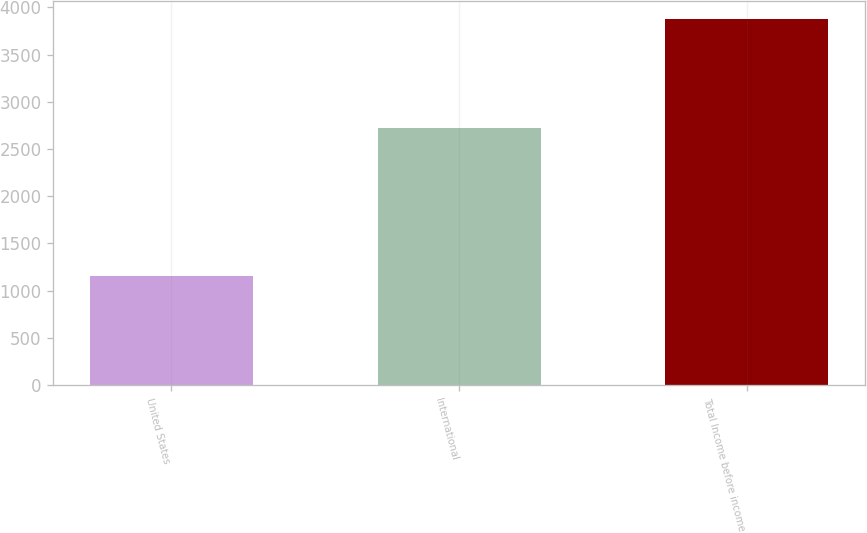Convert chart. <chart><loc_0><loc_0><loc_500><loc_500><bar_chart><fcel>United States<fcel>International<fcel>Total Income before income<nl><fcel>1155<fcel>2719<fcel>3874<nl></chart> 